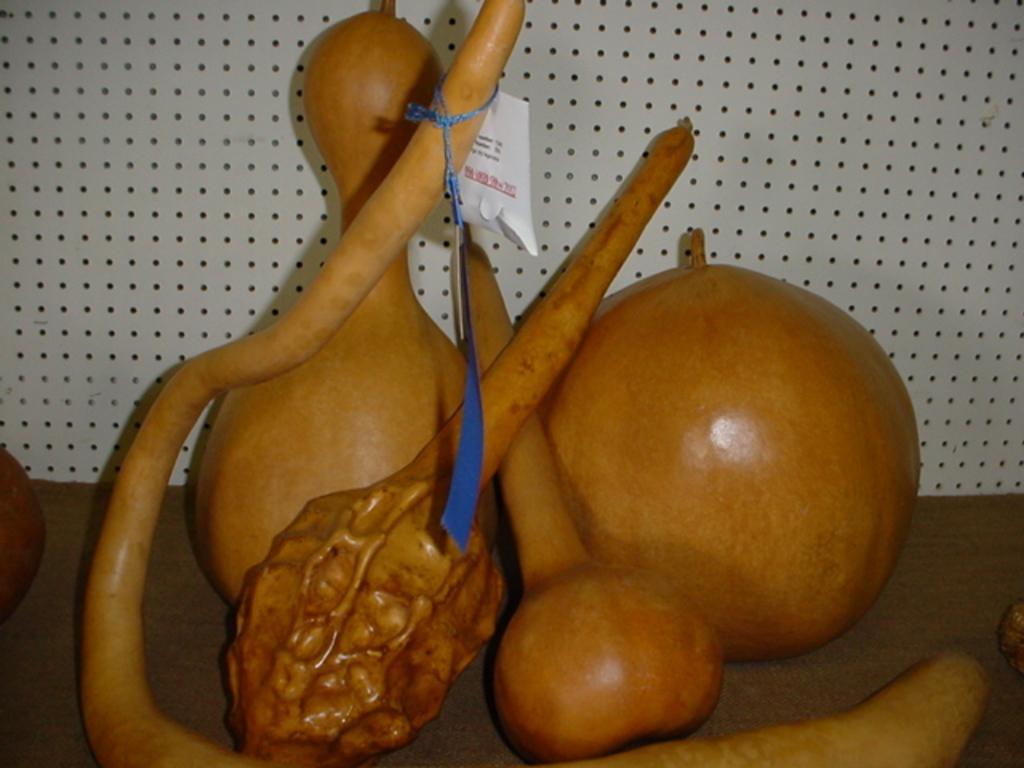In one or two sentences, can you explain what this image depicts? In this image there are few objects. 